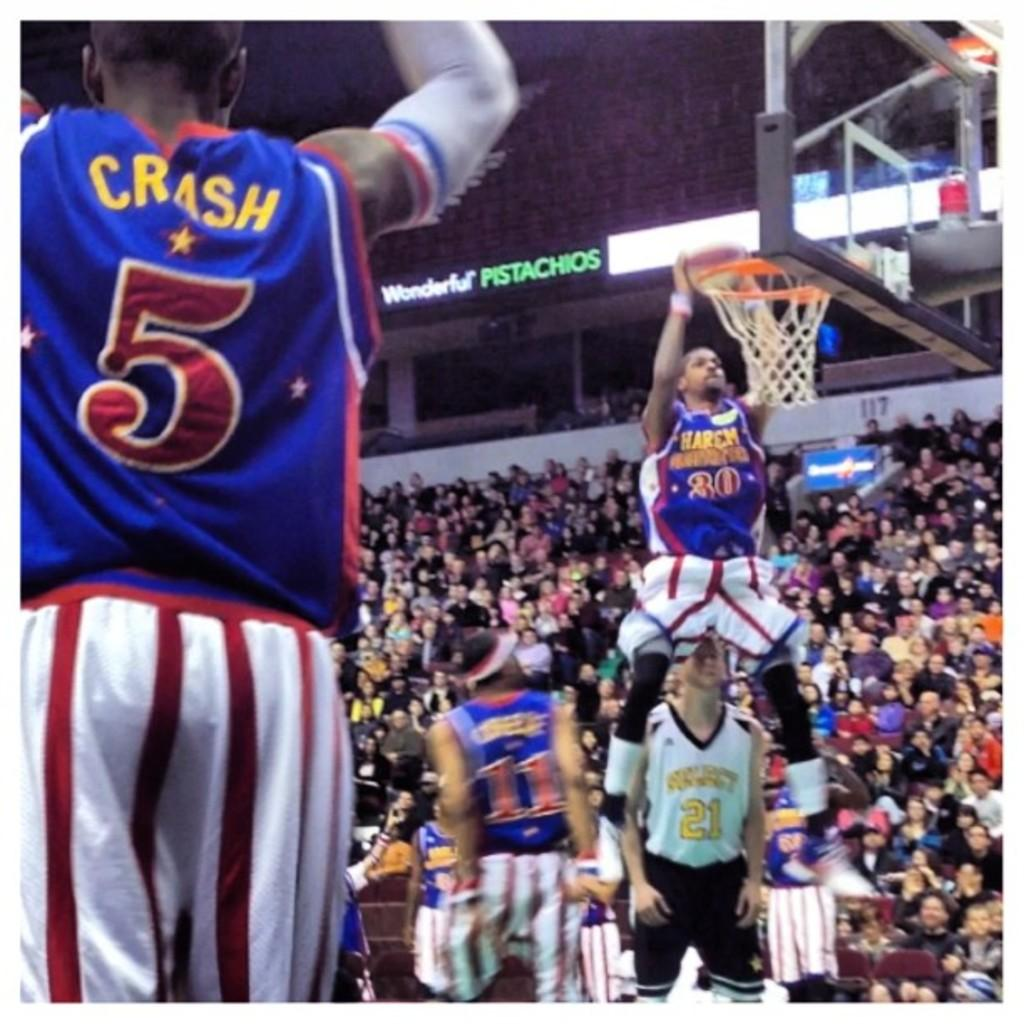<image>
Create a compact narrative representing the image presented. a basketball game going on, with player CRASH 5 up front, and Wonderful Pistashios on the banner ad. 